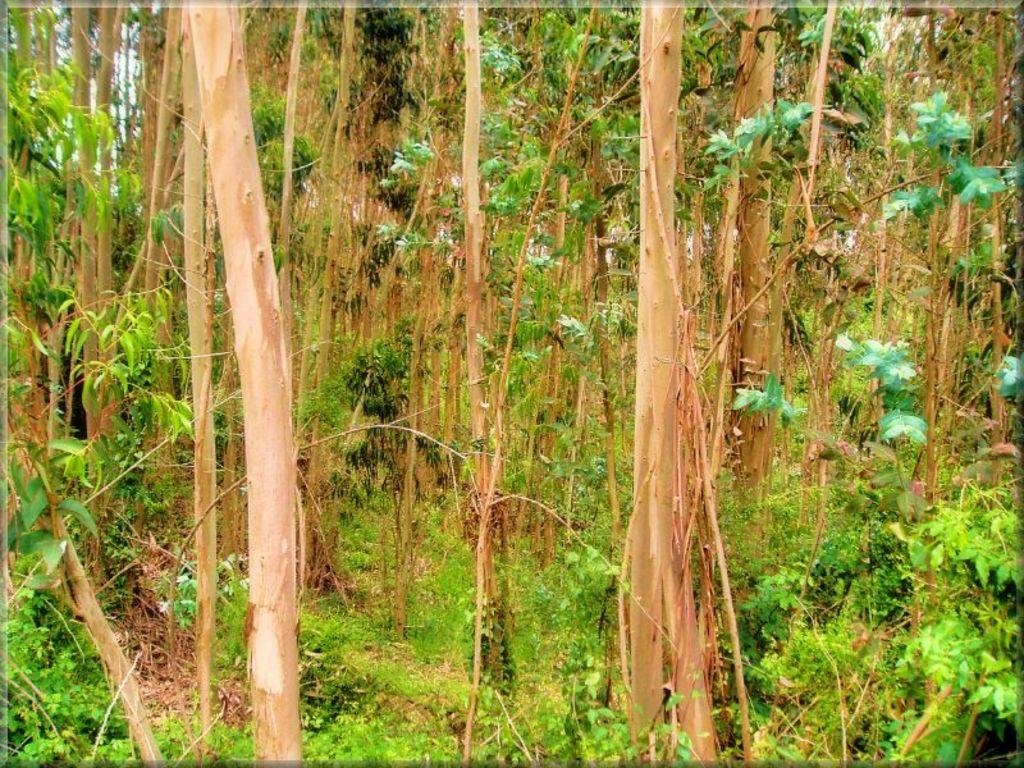What type of vegetation can be seen in the image? There are trees and plants in the image. Can you describe the specific types of plants in the image? The provided facts do not specify the types of plants, only that there are plants in the image. What is the primary setting of the image? The primary setting of the image is outdoors, given the presence of trees and plants. What type of drum can be heard in the image? There is no drum or sound present in the image; it only features trees and plants. Are there any giants visible in the image? There are no giants present in the image; it only features trees and plants. 